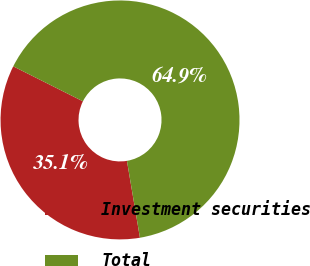Convert chart to OTSL. <chart><loc_0><loc_0><loc_500><loc_500><pie_chart><fcel>Investment securities<fcel>Total<nl><fcel>35.07%<fcel>64.93%<nl></chart> 